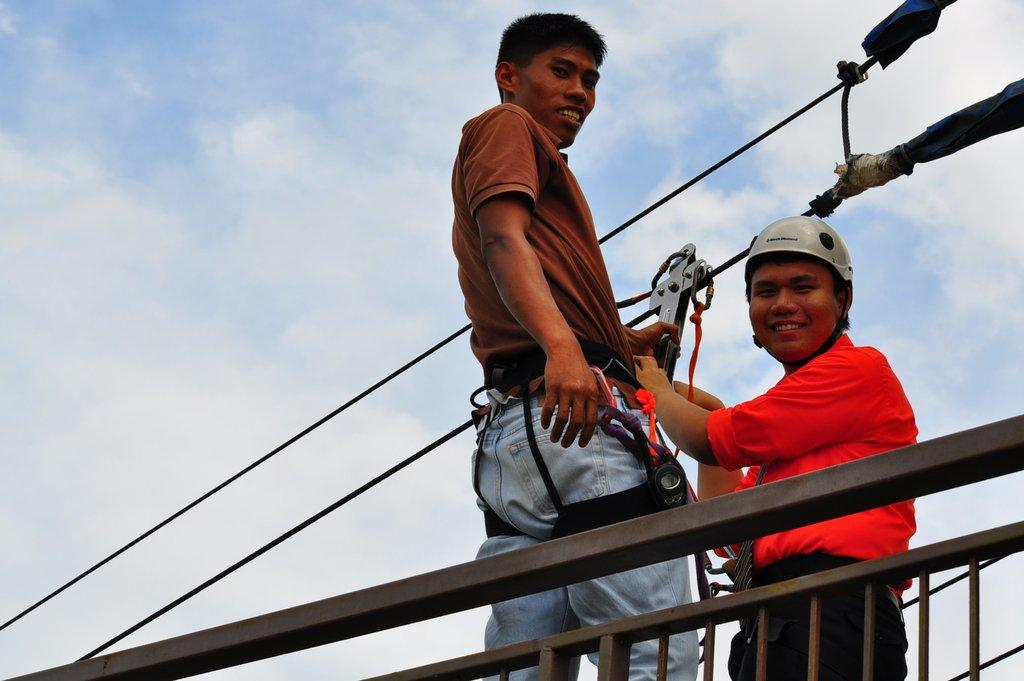What is the person in the image wearing? There is a person wearing a red dress in the image. What is the person in the red dress holding? The person is holding an object attached to a wire. Is there anyone else in the image besides the person in the red dress? Yes, there is another person standing beside the person in the red dress. What can be seen in the background of the image? There is a fence in the image. What type of cannon is being used to help the person in the red dress in the image? There is no cannon present in the image, and the person in the red dress is not receiving any help from a cannon. 